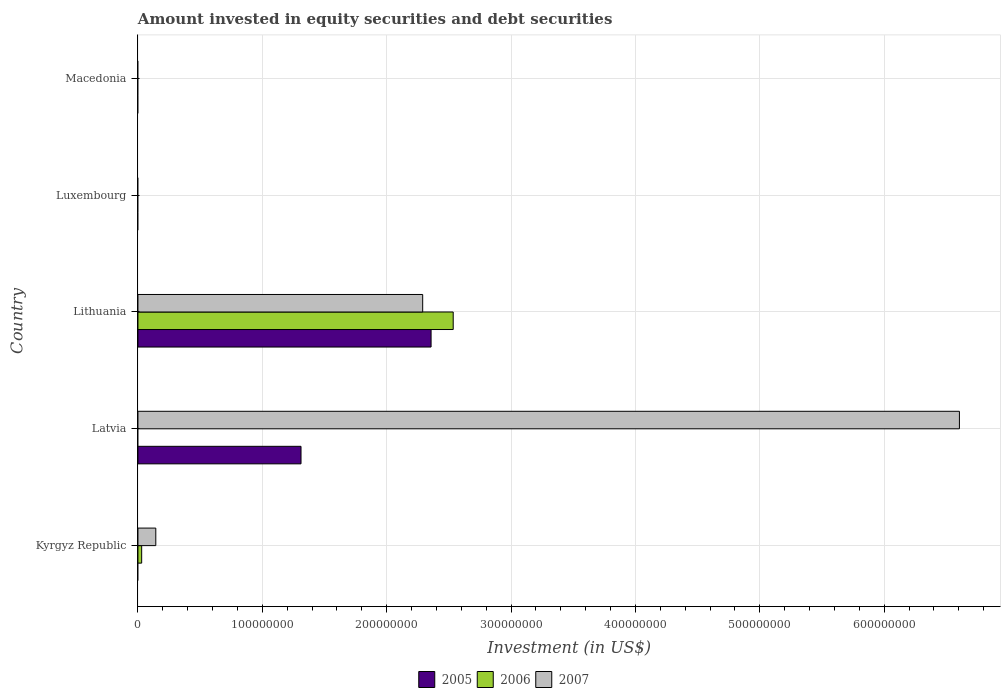How many different coloured bars are there?
Your answer should be compact. 3. How many bars are there on the 2nd tick from the top?
Provide a succinct answer. 0. How many bars are there on the 2nd tick from the bottom?
Keep it short and to the point. 2. What is the label of the 2nd group of bars from the top?
Your answer should be very brief. Luxembourg. What is the amount invested in equity securities and debt securities in 2007 in Latvia?
Provide a succinct answer. 6.60e+08. Across all countries, what is the maximum amount invested in equity securities and debt securities in 2006?
Offer a very short reply. 2.53e+08. Across all countries, what is the minimum amount invested in equity securities and debt securities in 2006?
Your response must be concise. 0. In which country was the amount invested in equity securities and debt securities in 2007 maximum?
Your answer should be very brief. Latvia. What is the total amount invested in equity securities and debt securities in 2005 in the graph?
Offer a very short reply. 3.67e+08. What is the difference between the amount invested in equity securities and debt securities in 2007 in Kyrgyz Republic and that in Latvia?
Your answer should be compact. -6.46e+08. What is the average amount invested in equity securities and debt securities in 2005 per country?
Keep it short and to the point. 7.34e+07. What is the difference between the amount invested in equity securities and debt securities in 2006 and amount invested in equity securities and debt securities in 2007 in Lithuania?
Keep it short and to the point. 2.45e+07. In how many countries, is the amount invested in equity securities and debt securities in 2007 greater than 400000000 US$?
Your response must be concise. 1. What is the difference between the highest and the second highest amount invested in equity securities and debt securities in 2007?
Provide a succinct answer. 4.32e+08. What is the difference between the highest and the lowest amount invested in equity securities and debt securities in 2007?
Offer a very short reply. 6.60e+08. In how many countries, is the amount invested in equity securities and debt securities in 2005 greater than the average amount invested in equity securities and debt securities in 2005 taken over all countries?
Provide a succinct answer. 2. Is it the case that in every country, the sum of the amount invested in equity securities and debt securities in 2005 and amount invested in equity securities and debt securities in 2007 is greater than the amount invested in equity securities and debt securities in 2006?
Offer a very short reply. No. How many bars are there?
Your response must be concise. 7. What is the difference between two consecutive major ticks on the X-axis?
Your response must be concise. 1.00e+08. Are the values on the major ticks of X-axis written in scientific E-notation?
Provide a succinct answer. No. How many legend labels are there?
Offer a terse response. 3. What is the title of the graph?
Your answer should be very brief. Amount invested in equity securities and debt securities. What is the label or title of the X-axis?
Your answer should be compact. Investment (in US$). What is the label or title of the Y-axis?
Give a very brief answer. Country. What is the Investment (in US$) of 2006 in Kyrgyz Republic?
Provide a succinct answer. 2.98e+06. What is the Investment (in US$) in 2007 in Kyrgyz Republic?
Ensure brevity in your answer.  1.43e+07. What is the Investment (in US$) in 2005 in Latvia?
Provide a short and direct response. 1.31e+08. What is the Investment (in US$) of 2006 in Latvia?
Provide a succinct answer. 0. What is the Investment (in US$) of 2007 in Latvia?
Your answer should be very brief. 6.60e+08. What is the Investment (in US$) in 2005 in Lithuania?
Your answer should be very brief. 2.36e+08. What is the Investment (in US$) in 2006 in Lithuania?
Provide a succinct answer. 2.53e+08. What is the Investment (in US$) in 2007 in Lithuania?
Provide a short and direct response. 2.29e+08. What is the Investment (in US$) of 2005 in Luxembourg?
Provide a short and direct response. 0. What is the Investment (in US$) in 2007 in Luxembourg?
Keep it short and to the point. 0. Across all countries, what is the maximum Investment (in US$) of 2005?
Your response must be concise. 2.36e+08. Across all countries, what is the maximum Investment (in US$) of 2006?
Your answer should be very brief. 2.53e+08. Across all countries, what is the maximum Investment (in US$) in 2007?
Your response must be concise. 6.60e+08. Across all countries, what is the minimum Investment (in US$) of 2006?
Offer a very short reply. 0. What is the total Investment (in US$) of 2005 in the graph?
Your response must be concise. 3.67e+08. What is the total Investment (in US$) of 2006 in the graph?
Ensure brevity in your answer.  2.56e+08. What is the total Investment (in US$) of 2007 in the graph?
Make the answer very short. 9.04e+08. What is the difference between the Investment (in US$) of 2007 in Kyrgyz Republic and that in Latvia?
Make the answer very short. -6.46e+08. What is the difference between the Investment (in US$) of 2006 in Kyrgyz Republic and that in Lithuania?
Your response must be concise. -2.50e+08. What is the difference between the Investment (in US$) in 2007 in Kyrgyz Republic and that in Lithuania?
Offer a terse response. -2.15e+08. What is the difference between the Investment (in US$) of 2005 in Latvia and that in Lithuania?
Make the answer very short. -1.05e+08. What is the difference between the Investment (in US$) in 2007 in Latvia and that in Lithuania?
Provide a succinct answer. 4.32e+08. What is the difference between the Investment (in US$) of 2006 in Kyrgyz Republic and the Investment (in US$) of 2007 in Latvia?
Provide a succinct answer. -6.57e+08. What is the difference between the Investment (in US$) of 2006 in Kyrgyz Republic and the Investment (in US$) of 2007 in Lithuania?
Offer a terse response. -2.26e+08. What is the difference between the Investment (in US$) in 2005 in Latvia and the Investment (in US$) in 2006 in Lithuania?
Keep it short and to the point. -1.22e+08. What is the difference between the Investment (in US$) in 2005 in Latvia and the Investment (in US$) in 2007 in Lithuania?
Provide a succinct answer. -9.78e+07. What is the average Investment (in US$) of 2005 per country?
Offer a very short reply. 7.34e+07. What is the average Investment (in US$) of 2006 per country?
Provide a succinct answer. 5.13e+07. What is the average Investment (in US$) of 2007 per country?
Provide a short and direct response. 1.81e+08. What is the difference between the Investment (in US$) of 2006 and Investment (in US$) of 2007 in Kyrgyz Republic?
Offer a terse response. -1.14e+07. What is the difference between the Investment (in US$) in 2005 and Investment (in US$) in 2007 in Latvia?
Your response must be concise. -5.29e+08. What is the difference between the Investment (in US$) in 2005 and Investment (in US$) in 2006 in Lithuania?
Offer a terse response. -1.78e+07. What is the difference between the Investment (in US$) of 2005 and Investment (in US$) of 2007 in Lithuania?
Provide a short and direct response. 6.75e+06. What is the difference between the Investment (in US$) of 2006 and Investment (in US$) of 2007 in Lithuania?
Provide a succinct answer. 2.45e+07. What is the ratio of the Investment (in US$) of 2007 in Kyrgyz Republic to that in Latvia?
Provide a succinct answer. 0.02. What is the ratio of the Investment (in US$) of 2006 in Kyrgyz Republic to that in Lithuania?
Offer a very short reply. 0.01. What is the ratio of the Investment (in US$) of 2007 in Kyrgyz Republic to that in Lithuania?
Your answer should be very brief. 0.06. What is the ratio of the Investment (in US$) in 2005 in Latvia to that in Lithuania?
Keep it short and to the point. 0.56. What is the ratio of the Investment (in US$) of 2007 in Latvia to that in Lithuania?
Keep it short and to the point. 2.89. What is the difference between the highest and the second highest Investment (in US$) in 2007?
Provide a short and direct response. 4.32e+08. What is the difference between the highest and the lowest Investment (in US$) of 2005?
Your response must be concise. 2.36e+08. What is the difference between the highest and the lowest Investment (in US$) in 2006?
Offer a terse response. 2.53e+08. What is the difference between the highest and the lowest Investment (in US$) of 2007?
Your response must be concise. 6.60e+08. 